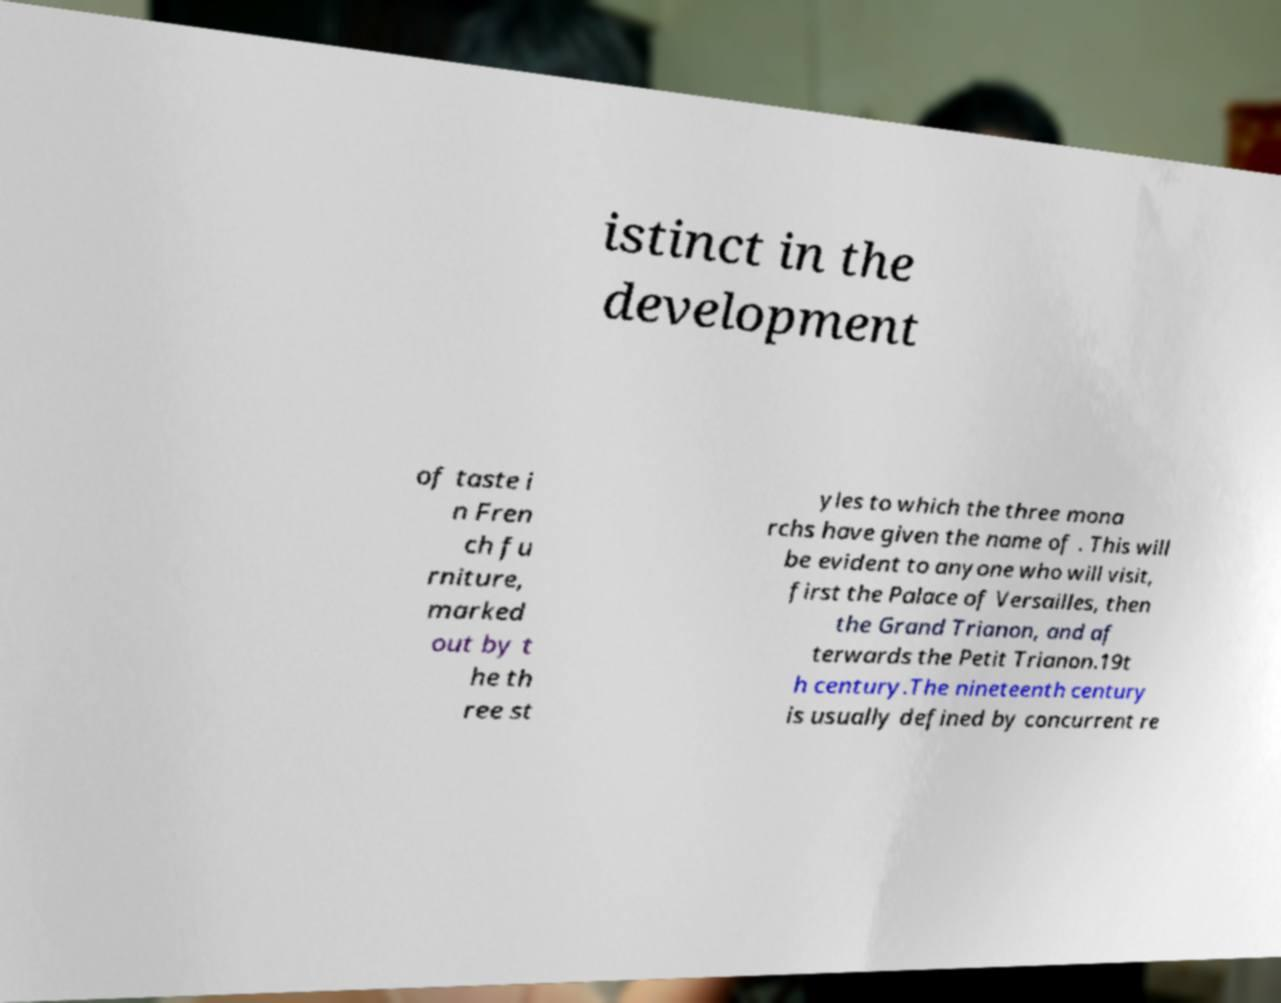Please identify and transcribe the text found in this image. istinct in the development of taste i n Fren ch fu rniture, marked out by t he th ree st yles to which the three mona rchs have given the name of . This will be evident to anyone who will visit, first the Palace of Versailles, then the Grand Trianon, and af terwards the Petit Trianon.19t h century.The nineteenth century is usually defined by concurrent re 